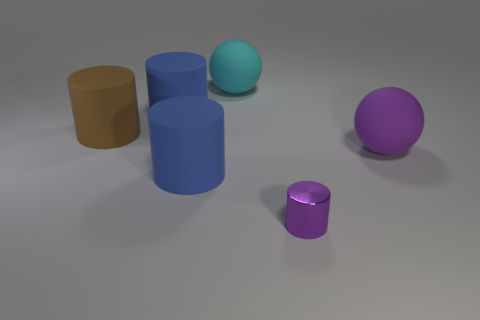There is a thing that is both on the right side of the cyan thing and left of the large purple rubber object; what material is it?
Your answer should be very brief. Metal. Is the number of blue matte objects less than the number of big brown rubber objects?
Make the answer very short. No. Is the shape of the purple metallic thing the same as the large blue rubber thing in front of the brown matte object?
Offer a very short reply. Yes. Do the blue cylinder that is in front of the brown object and the brown object have the same size?
Give a very brief answer. Yes. There is a purple thing that is the same size as the cyan matte object; what shape is it?
Keep it short and to the point. Sphere. Does the big cyan object have the same shape as the small purple object?
Offer a very short reply. No. How many other small metallic things have the same shape as the brown thing?
Offer a very short reply. 1. What number of blue objects are on the left side of the purple metallic cylinder?
Your answer should be compact. 2. Do the big rubber ball on the right side of the small purple object and the small cylinder have the same color?
Your response must be concise. Yes. How many blue shiny blocks have the same size as the purple rubber sphere?
Ensure brevity in your answer.  0. 